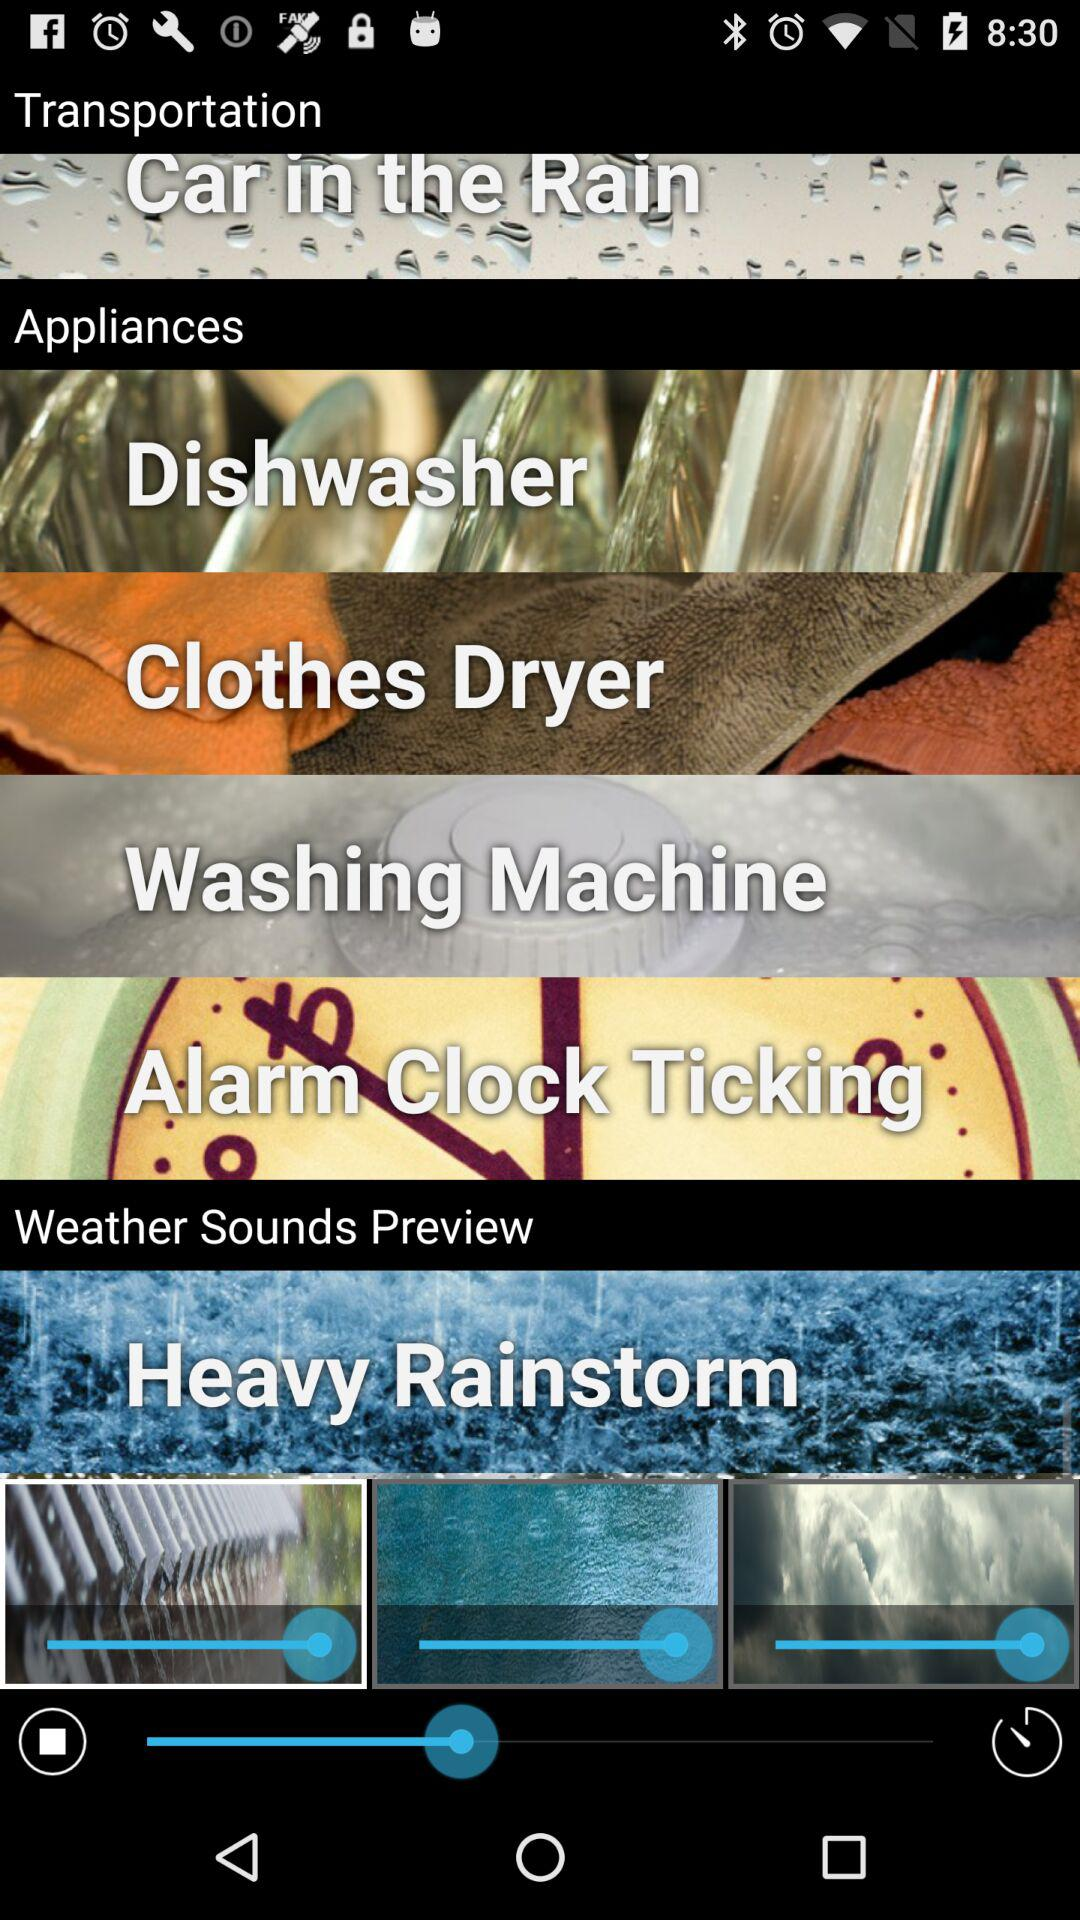What are the different types of appliances? The different types of appliances are "Dishwasher", "Clothes Dryer", "Washing Machine" and "Alarm Clock Ticking". 